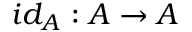<formula> <loc_0><loc_0><loc_500><loc_500>i d _ { A } \colon A \to A</formula> 